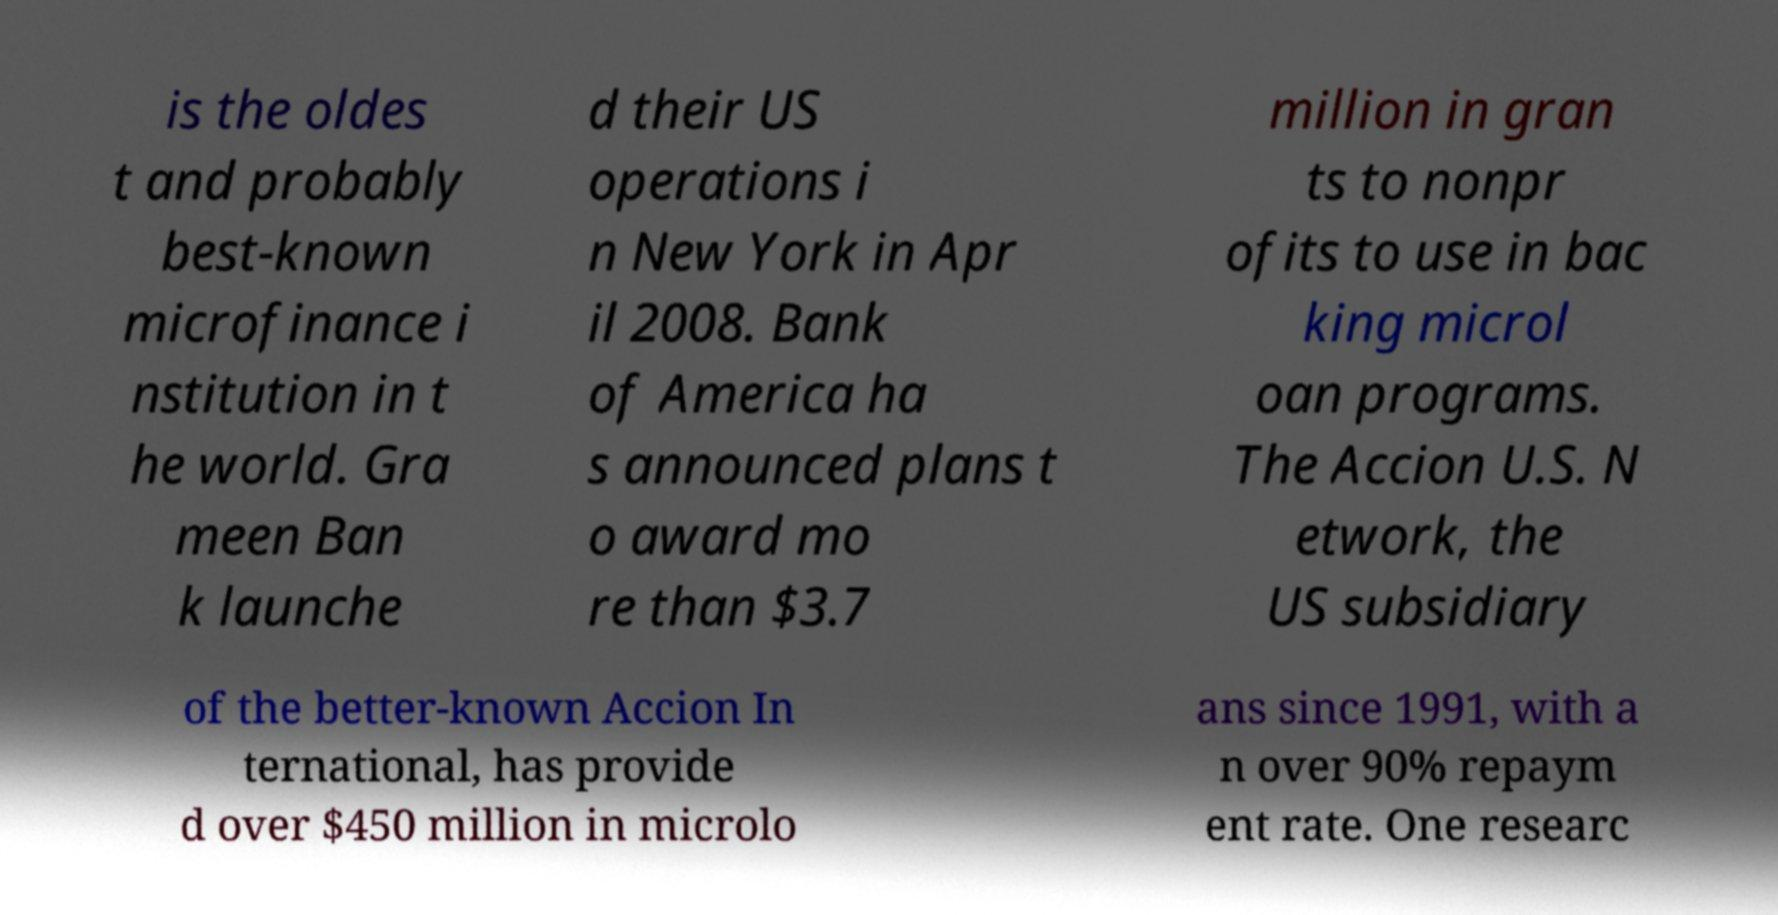What messages or text are displayed in this image? I need them in a readable, typed format. is the oldes t and probably best-known microfinance i nstitution in t he world. Gra meen Ban k launche d their US operations i n New York in Apr il 2008. Bank of America ha s announced plans t o award mo re than $3.7 million in gran ts to nonpr ofits to use in bac king microl oan programs. The Accion U.S. N etwork, the US subsidiary of the better-known Accion In ternational, has provide d over $450 million in microlo ans since 1991, with a n over 90% repaym ent rate. One researc 